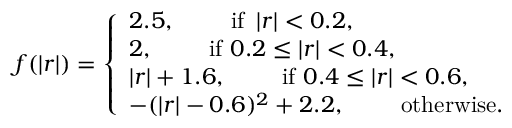<formula> <loc_0><loc_0><loc_500><loc_500>f ( \left | r \right | ) = \left \{ \begin{array} { l l } { 2 . 5 , \quad i f \ \left | r \right | < 0 . 2 , } \\ { 2 , \quad i f \ 0 . 2 \leq \left | r \right | < 0 . 4 , } \\ { \left | r \right | + 1 . 6 , \quad i f \ 0 . 4 \leq \left | r \right | < 0 . 6 , } \\ { - ( \left | r \right | - 0 . 6 ) ^ { 2 } + 2 . 2 , \quad o t h e r w i s e . } \end{array}</formula> 